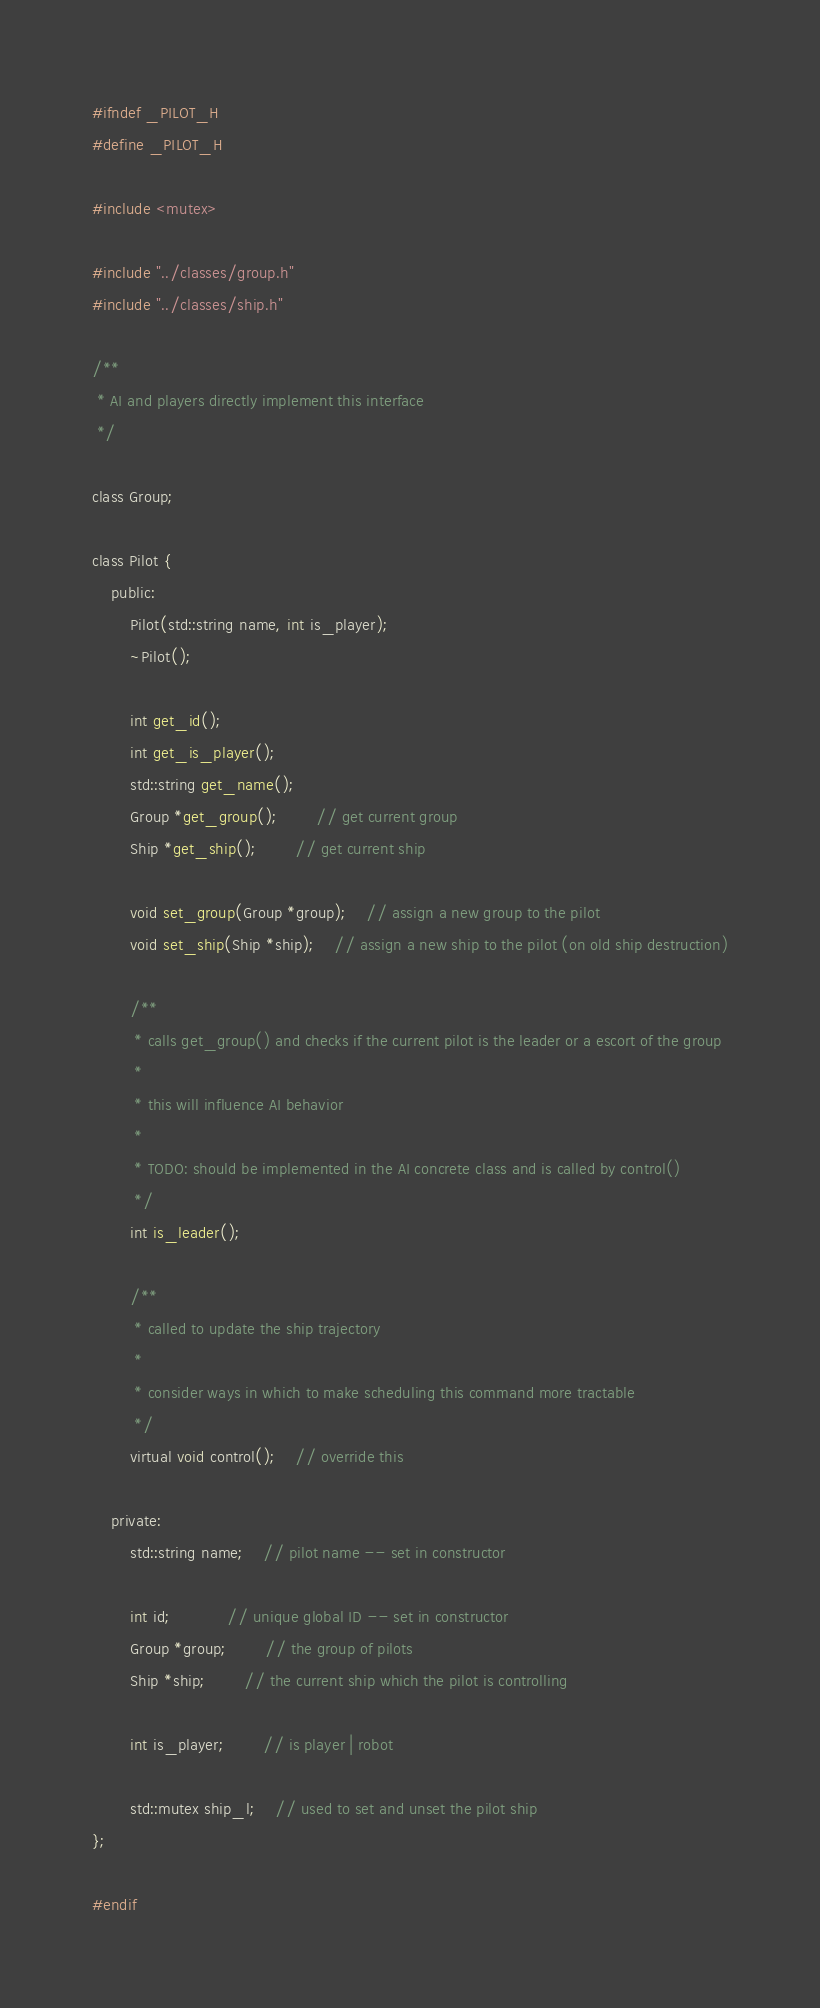Convert code to text. <code><loc_0><loc_0><loc_500><loc_500><_C_>#ifndef _PILOT_H
#define _PILOT_H

#include <mutex>

#include "../classes/group.h"
#include "../classes/ship.h"

/**
 * AI and players directly implement this interface
 */

class Group;

class Pilot {
	public:
		Pilot(std::string name, int is_player);
		~Pilot();

		int get_id();
		int get_is_player();
		std::string get_name();
		Group *get_group();		// get current group
		Ship *get_ship();		// get current ship

		void set_group(Group *group);	// assign a new group to the pilot
		void set_ship(Ship *ship);	// assign a new ship to the pilot (on old ship destruction)

		/**
		 * calls get_group() and checks if the current pilot is the leader or a escort of the group
		 *
		 * this will influence AI behavior
		 *
		 * TODO: should be implemented in the AI concrete class and is called by control()
		 */
		int is_leader();

		/**
		 * called to update the ship trajectory
		 *
		 * consider ways in which to make scheduling this command more tractable
		 */
		virtual void control();	// override this

	private:
		std::string name;	// pilot name -- set in constructor

		int id;			// unique global ID -- set in constructor
		Group *group;		// the group of pilots
		Ship *ship;		// the current ship which the pilot is controlling

		int is_player;		// is player | robot

		std::mutex ship_l;	// used to set and unset the pilot ship
};

#endif
</code> 